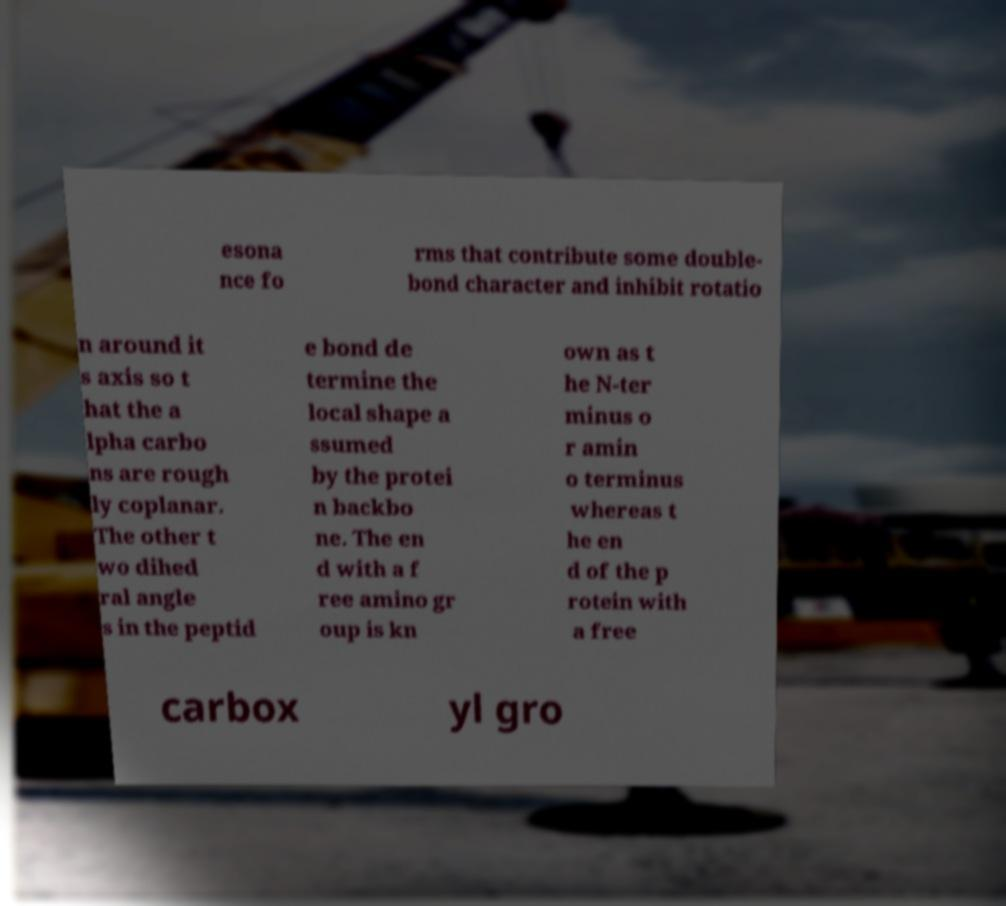What messages or text are displayed in this image? I need them in a readable, typed format. esona nce fo rms that contribute some double- bond character and inhibit rotatio n around it s axis so t hat the a lpha carbo ns are rough ly coplanar. The other t wo dihed ral angle s in the peptid e bond de termine the local shape a ssumed by the protei n backbo ne. The en d with a f ree amino gr oup is kn own as t he N-ter minus o r amin o terminus whereas t he en d of the p rotein with a free carbox yl gro 